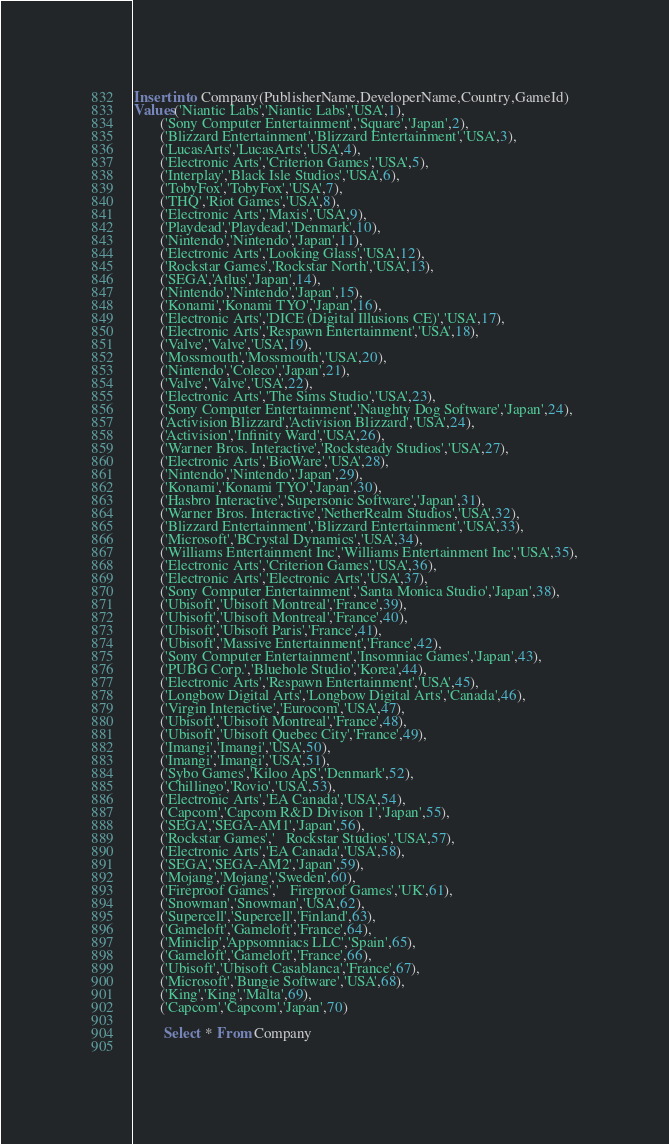Convert code to text. <code><loc_0><loc_0><loc_500><loc_500><_SQL_>Insert into Company(PublisherName,DeveloperName,Country,GameId)
Values('Niantic Labs','Niantic Labs','USA',1),
	   ('Sony Computer Entertainment','Square','Japan',2),
	   ('Blizzard Entertainment','Blizzard Entertainment','USA',3),
	   ('LucasArts','LucasArts','USA',4),
	   ('Electronic Arts','Criterion Games','USA',5),
	   ('Interplay','Black Isle Studios','USA',6),
	   ('TobyFox','TobyFox','USA',7),
	   ('THQ','Riot Games','USA',8),
	   ('Electronic Arts','Maxis','USA',9),
	   ('Playdead','Playdead','Denmark',10),
	   ('Nintendo','Nintendo','Japan',11),
	   ('Electronic Arts','Looking Glass','USA',12),
	   ('Rockstar Games','Rockstar North','USA',13),
	   ('SEGA','Atlus','Japan',14),
	   ('Nintendo','Nintendo','Japan',15),
	   ('Konami','Konami TYO','Japan',16),
	   ('Electronic Arts','DICE (Digital Illusions CE)','USA',17),
	   ('Electronic Arts','Respawn Entertainment','USA',18),
	   ('Valve','Valve','USA',19),
	   ('Mossmouth','Mossmouth','USA',20),
	   ('Nintendo','Coleco','Japan',21),
	   ('Valve','Valve','USA',22),
	   ('Electronic Arts','The Sims Studio','USA',23),
	   ('Sony Computer Entertainment','Naughty Dog Software','Japan',24),
	   ('Activision Blizzard','Activision Blizzard','USA',24),
	   ('Activision','Infinity Ward','USA',26),
	   ('Warner Bros. Interactive','Rocksteady Studios','USA',27),
	   ('Electronic Arts','BioWare','USA',28),
	   ('Nintendo','Nintendo','Japan',29),
	   ('Konami','Konami TYO','Japan',30),
	   ('Hasbro Interactive','Supersonic Software','Japan',31),
	   ('Warner Bros. Interactive','NetherRealm Studios','USA',32),
	   ('Blizzard Entertainment','Blizzard Entertainment','USA',33),
	   ('Microsoft','BCrystal Dynamics','USA',34),
	   ('Williams Entertainment Inc','Williams Entertainment Inc','USA',35),
	   ('Electronic Arts','Criterion Games','USA',36),
	   ('Electronic Arts','Electronic Arts','USA',37),
	   ('Sony Computer Entertainment','Santa Monica Studio','Japan',38),
	   ('Ubisoft','Ubisoft Montreal','France',39),
	   ('Ubisoft','Ubisoft Montreal','France',40),
	   ('Ubisoft','Ubisoft Paris','France',41),
	   ('Ubisoft','Massive Entertainment','France',42),
	   ('Sony Computer Entertainment','Insomniac Games','Japan',43),
	   ('PUBG Corp.','Bluehole Studio','Korea',44),
	   ('Electronic Arts','Respawn Entertainment','USA',45),
	   ('Longbow Digital Arts','Longbow Digital Arts','Canada',46),
	   ('Virgin Interactive','Eurocom','USA',47),
	   ('Ubisoft','Ubisoft Montreal','France',48),
	   ('Ubisoft','Ubisoft Quebec City','France',49),
	   ('Imangi','Imangi','USA',50),
	   ('Imangi','Imangi','USA',51),
	   ('Sybo Games','Kiloo ApS','Denmark',52),
	   ('Chillingo','Rovio','USA',53),
	   ('Electronic Arts','EA Canada','USA',54),
	   ('Capcom','Capcom R&D Divison 1','Japan',55),
	   ('SEGA','SEGA-AM1','Japan',56),
	   ('Rockstar Games','	Rockstar Studios','USA',57),
	   ('Electronic Arts','EA Canada','USA',58),
	   ('SEGA','SEGA-AM2','Japan',59),
	   ('Mojang','Mojang','Sweden',60),
	   ('Fireproof Games','	Fireproof Games','UK',61),
	   ('Snowman','Snowman','USA',62),
	   ('Supercell','Supercell','Finland',63),
	   ('Gameloft','Gameloft','France',64),
	   ('Miniclip','Appsomniacs LLC','Spain',65),
	   ('Gameloft','Gameloft','France',66),
	   ('Ubisoft','Ubisoft Casablanca','France',67),
	   ('Microsoft','Bungie Software','USA',68),
	   ('King','King','Malta',69),
	   ('Capcom','Capcom','Japan',70)

	   	Select * From Company
	   </code> 